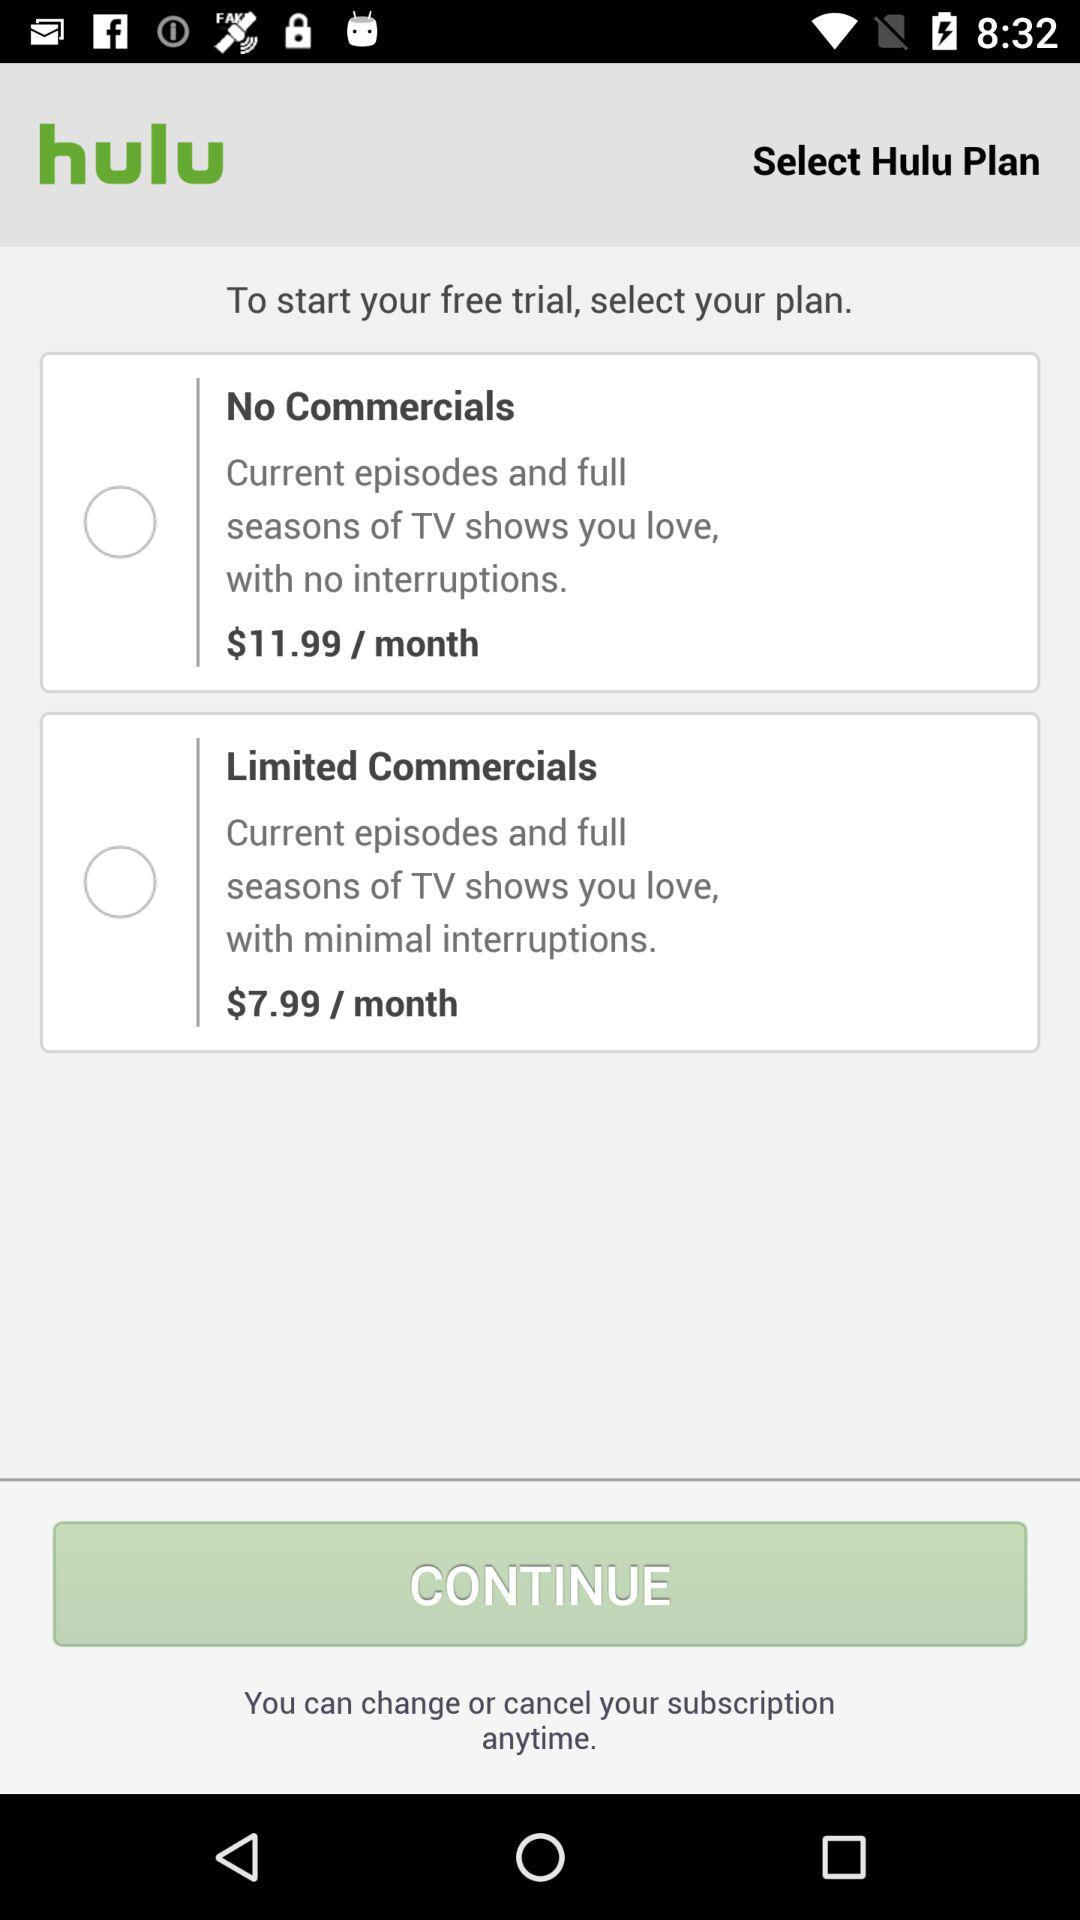What are the options for choosing the plan? The options for choosing the plan are "No Commercials" and "Limited Commercials". 